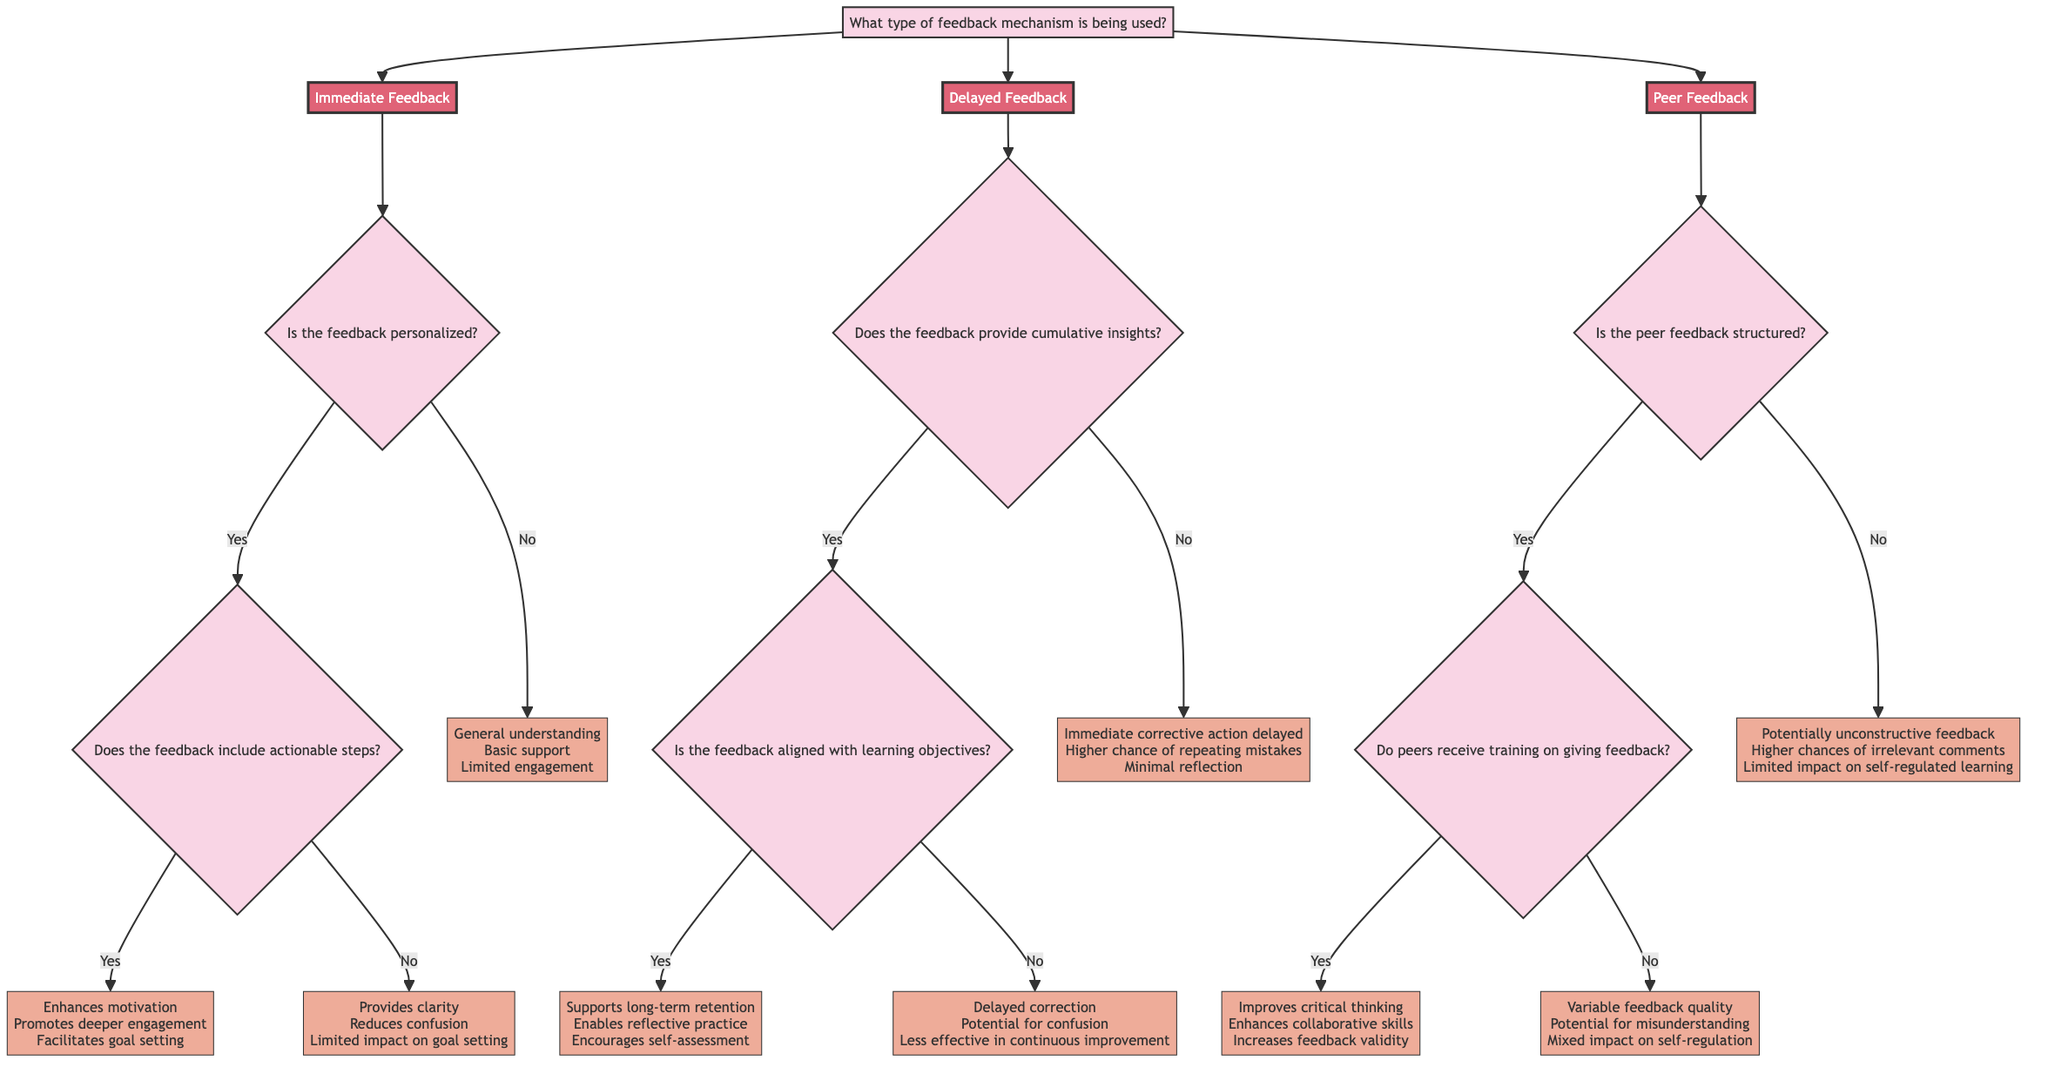What are the three feedback types in the diagram? The diagram identifies three feedback types: Immediate Feedback, Delayed Feedback, and Peer Feedback. This can be found as the branches originating from the root question.
Answer: Immediate Feedback, Delayed Feedback, Peer Feedback What is the effect of immediate feedback if it is personalized and includes actionable steps? According to the diagram, if immediate feedback is personalized and includes actionable steps, it enhances motivation, promotes deeper engagement, and facilitates goal setting. This is shown through the branches connected to "Yes" for both questions.
Answer: Enhances motivation, Promotes deeper engagement, Facilitates goal setting What happens if peer feedback is unstructured? The diagram specifies that unstructured peer feedback can lead to potentially unconstructive feedback, higher chances of irrelevant comments, and limited impact on self-regulated learning. This can be traced through the path leading to the "No" node under the question regarding structure.
Answer: Potentially unconstructive feedback, Higher chances of irrelevant comments, Limited impact on self-regulated learning How many outcomes are there for immediate feedback based on the personalization question? There are three potential outcomes for immediate feedback depending on whether it is personalized: if it's yes and includes actionable steps, if it's yes but does not include actionable steps, and if it's no. Hence, there are three outcomes.
Answer: Three What is the effect of delayed feedback not providing cumulative insights? The diagram states that if delayed feedback does not provide cumulative insights, it results in immediate corrective action being delayed, a higher chance of repeating mistakes, and minimal reflection. This follows the path under the "No" branch of cumulative insights.
Answer: Immediate corrective action delayed, Higher chance of repeating mistakes, Minimal reflection What are the outcomes of cumulative insights in delayed feedback if aligned with learning objectives? If cumulative insights in delayed feedback are aligned with learning objectives, the effects listed in the diagram include supporting long-term retention, enabling reflective practice, and encouraging self-assessment. These outcomes follow the "Yes" path to both cumulative insights and alignment with objectives.
Answer: Supports long-term retention, Enables reflective practice, Encourages self-assessment 